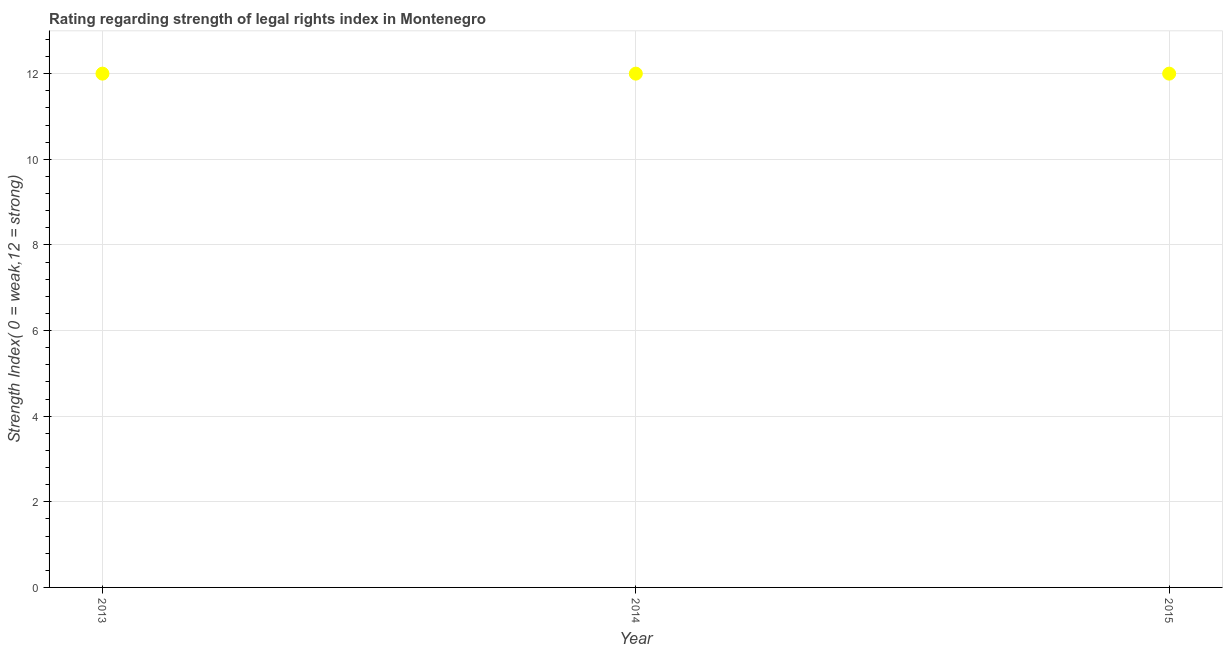What is the strength of legal rights index in 2013?
Provide a succinct answer. 12. Across all years, what is the maximum strength of legal rights index?
Your answer should be very brief. 12. Across all years, what is the minimum strength of legal rights index?
Give a very brief answer. 12. In which year was the strength of legal rights index minimum?
Your answer should be very brief. 2013. What is the sum of the strength of legal rights index?
Offer a very short reply. 36. What is the difference between the strength of legal rights index in 2014 and 2015?
Ensure brevity in your answer.  0. Do a majority of the years between 2015 and 2014 (inclusive) have strength of legal rights index greater than 2 ?
Make the answer very short. No. What is the ratio of the strength of legal rights index in 2013 to that in 2015?
Keep it short and to the point. 1. Is the strength of legal rights index in 2013 less than that in 2014?
Provide a short and direct response. No. Is the difference between the strength of legal rights index in 2014 and 2015 greater than the difference between any two years?
Keep it short and to the point. Yes. In how many years, is the strength of legal rights index greater than the average strength of legal rights index taken over all years?
Provide a succinct answer. 0. Does the strength of legal rights index monotonically increase over the years?
Your answer should be compact. No. How many dotlines are there?
Ensure brevity in your answer.  1. How many years are there in the graph?
Make the answer very short. 3. What is the difference between two consecutive major ticks on the Y-axis?
Make the answer very short. 2. Are the values on the major ticks of Y-axis written in scientific E-notation?
Keep it short and to the point. No. Does the graph contain grids?
Your response must be concise. Yes. What is the title of the graph?
Keep it short and to the point. Rating regarding strength of legal rights index in Montenegro. What is the label or title of the Y-axis?
Your response must be concise. Strength Index( 0 = weak,12 = strong). What is the Strength Index( 0 = weak,12 = strong) in 2013?
Give a very brief answer. 12. What is the Strength Index( 0 = weak,12 = strong) in 2014?
Your answer should be compact. 12. What is the difference between the Strength Index( 0 = weak,12 = strong) in 2014 and 2015?
Your answer should be very brief. 0. What is the ratio of the Strength Index( 0 = weak,12 = strong) in 2013 to that in 2015?
Provide a short and direct response. 1. What is the ratio of the Strength Index( 0 = weak,12 = strong) in 2014 to that in 2015?
Your response must be concise. 1. 